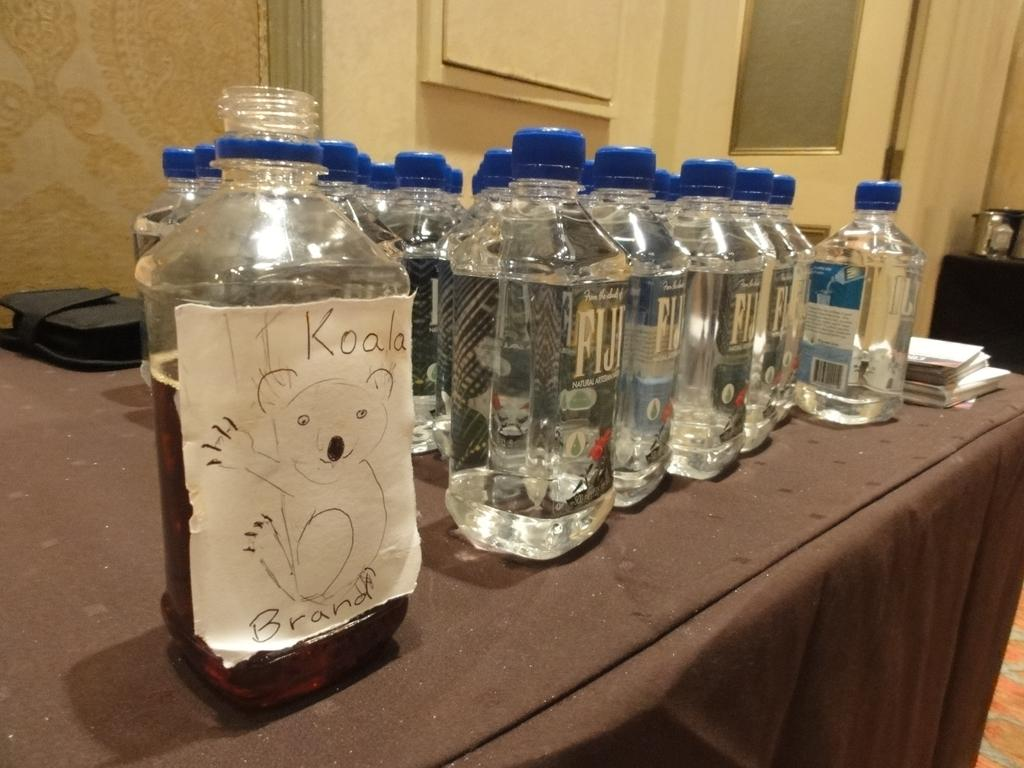<image>
Provide a brief description of the given image. A bunch of FIJI water bottles on a table but one is covered in a piece of paper with a Koala on it 